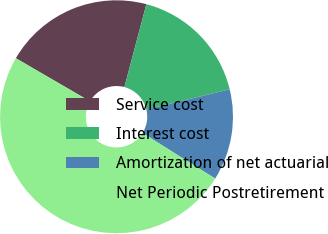Convert chart. <chart><loc_0><loc_0><loc_500><loc_500><pie_chart><fcel>Service cost<fcel>Interest cost<fcel>Amortization of net actuarial<fcel>Net Periodic Postretirement<nl><fcel>20.75%<fcel>17.08%<fcel>12.7%<fcel>49.47%<nl></chart> 